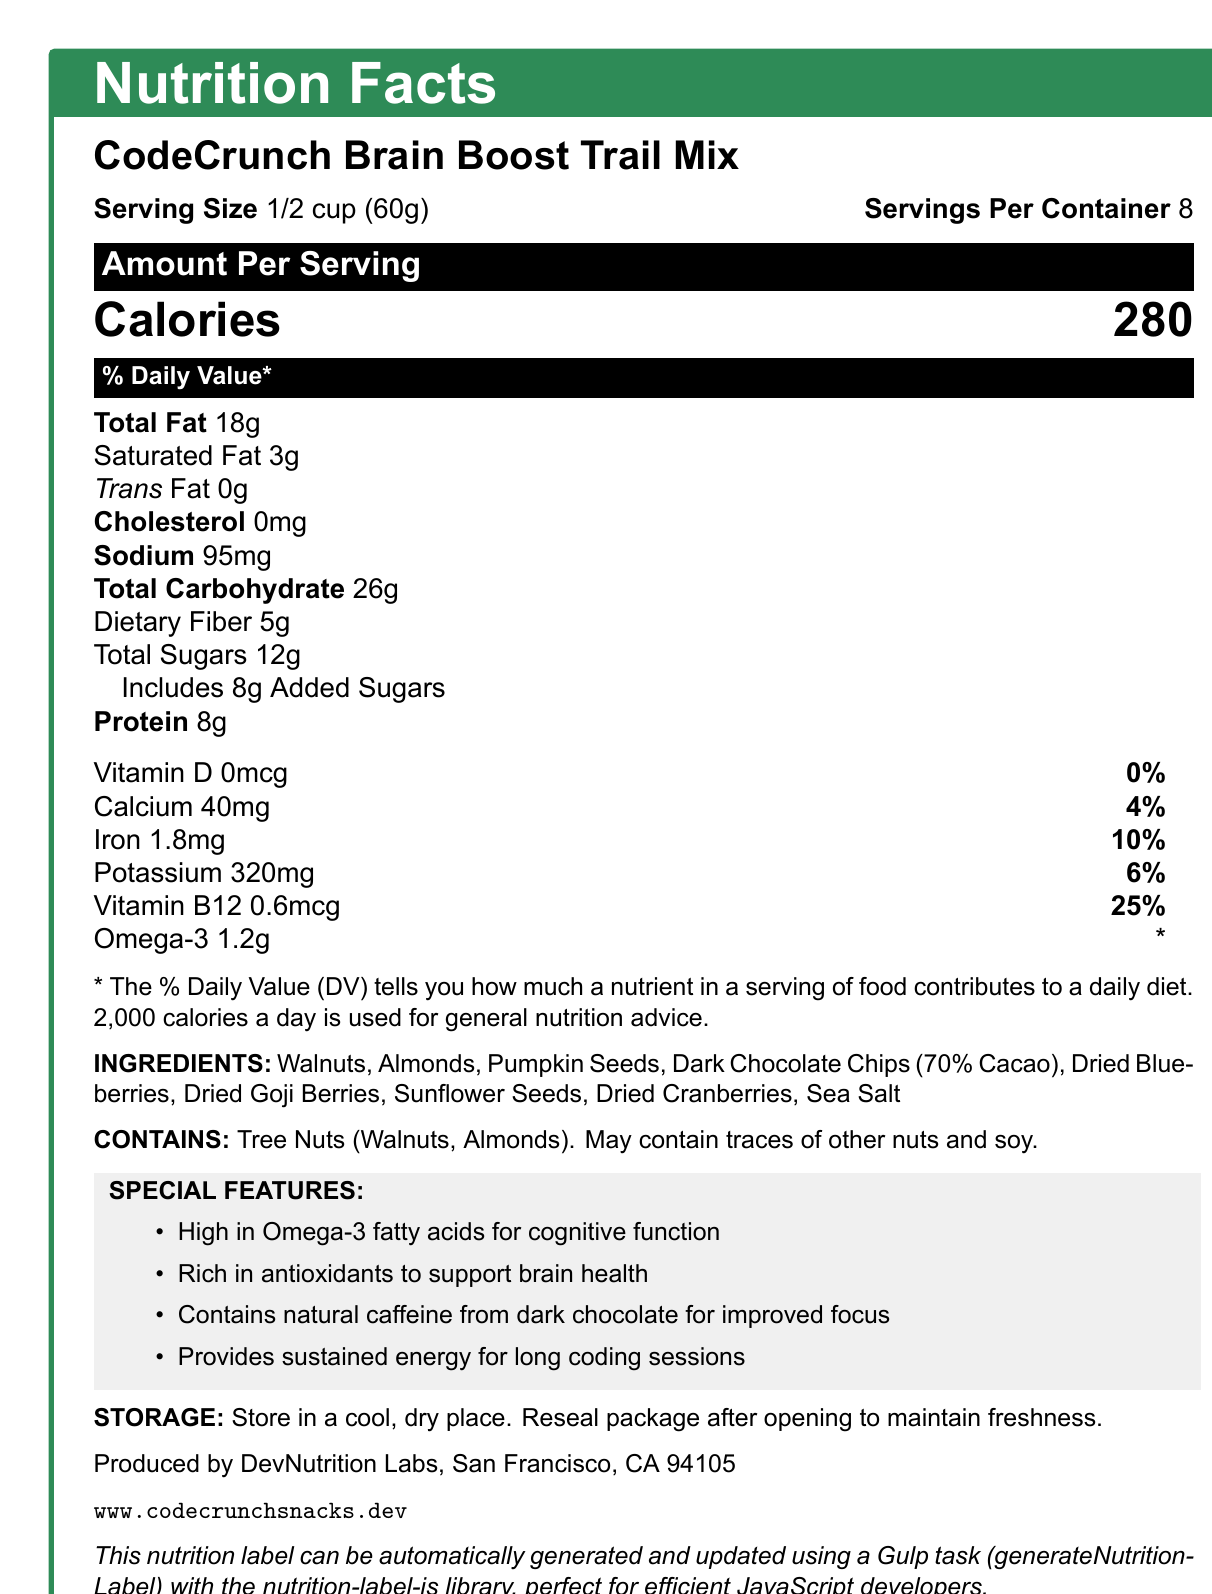What is the serving size of the CodeCrunch Brain Boost Trail Mix? According to the document, the serving size is specified as "1/2 cup (60g)".
Answer: 1/2 cup (60g) How many calories are there per serving of the trail mix? The document states that there are 280 calories per serving.
Answer: 280 calories What percentage of the daily value of dietary fiber does one serving provide? The document lists dietary fiber as providing 18% of the daily value per serving.
Answer: 18% Which ingredient in the trail mix provides natural caffeine? The special features section notes that the trail mix contains natural caffeine from dark chocolate.
Answer: Dark Chocolate Chips (70% Cacao) Which vitamins and minerals are listed on the nutrition label? The vitamins and minerals listed are Vitamin D, Calcium, Iron, Potassium, and Vitamin B12.
Answer: Vitamin D, Calcium, Iron, Potassium, Vitamin B12 What is the total fat content of one serving? The document shows that total fat content per serving is 18g.
Answer: 18g Which of the following best describes the Omega-3 content in one serving of the trail mix? A. 18g B. 5g C. 1.2g D. 0.6mcg The document mentions that one serving contains 1.2g of Omega-3.
Answer: C. 1.2g Which nutrient has the highest daily value percentage in one serving? A. Total Fat B. Saturated Fat C. Dietary Fiber D. Vitamin B12 Vitamin B12 has the highest daily value at 25%, according to the document.
Answer: D. Vitamin B12 Does the trail mix contain any trans fat? The nutrition label indicates that there are 0g of trans fat.
Answer: No Is there any information about the product's storage instructions? The document specifies to store the product in a cool, dry place and to reseal the package after opening to maintain freshness.
Answer: Yes Summarize the main idea of the document. The document offers all essential information for understanding the nutritional value and benefits of the trail mix, emphasizing its cognitive support and energy-sustaining properties, along with practical details about consumption and storage.
Answer: The document provides detailed nutrition information about CodeCrunch Brain Boost Trail Mix, including serving size, calories, various nutrients, ingredients, allergen information, special features for cognitive benefits and energy, storage instructions, and manufacturer details. What is the daily value percentage of cholesterol in one serving? The document lists cholesterol as 0mg with a 0% daily value.
Answer: 0% Which ingredient listed is not a type of nut or seed? The ingredients section includes dark chocolate chips, which aren't a nut or seed.
Answer: Dark Chocolate Chips (70% Cacao) Can you determine the exact quantity of each ingredient used in the trail mix? The document lists the ingredients but does not provide the specific quantity of each used in the trail mix.
Answer: Cannot be determined What type of coding library is mentioned for automating the nutrition label generation? A. matplotlib B. nutrition-label-js C. pandas D. React The automation note specifies the use of the nutrition-label-js library for generating and updating the nutrition label.
Answer: B. nutrition-label-js 